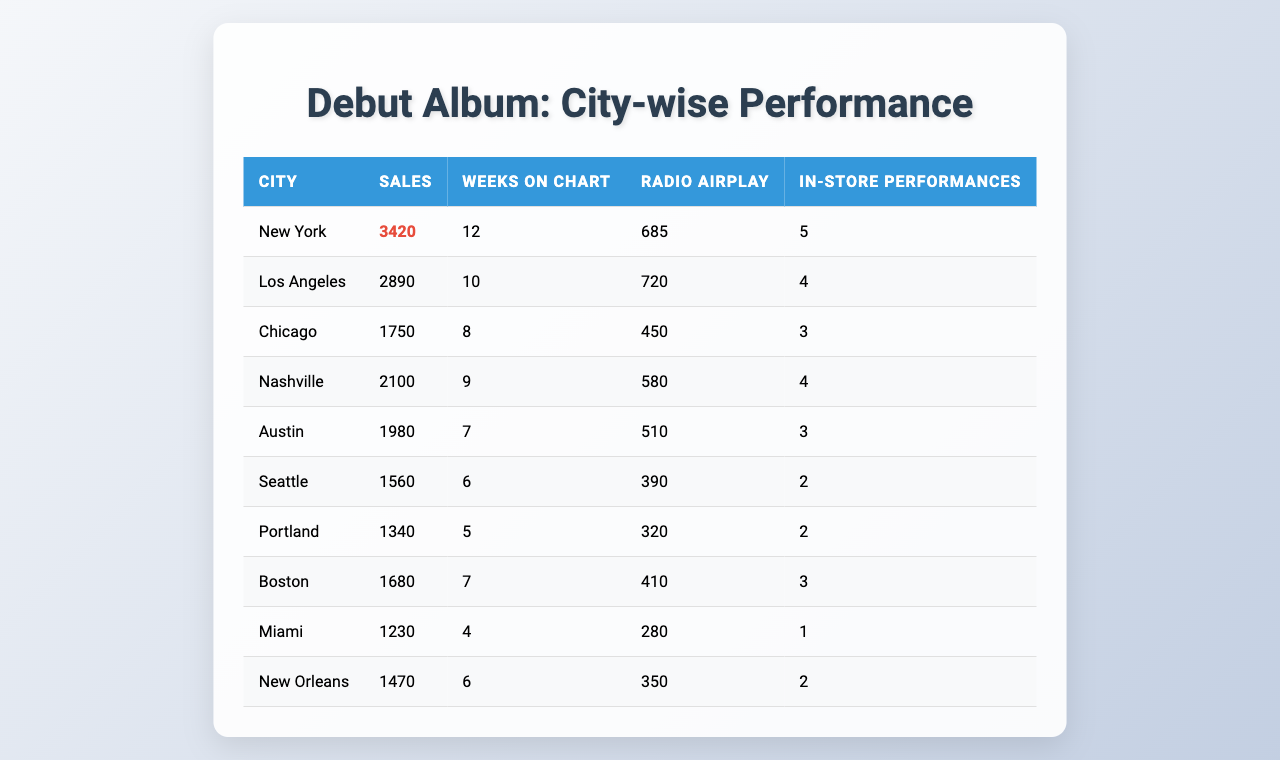What city had the highest sales? By looking at the "Sales" column in the table, New York has the highest sales figure at 3420.
Answer: New York Which city had the least number of in-store performances? Examining the "In-store Performances" column, Miami has the least with only 1 performance.
Answer: Miami What is the average number of weeks on the chart across all cities? To find the average, sum the weeks (12 + 10 + 8 + 9 + 7 + 6 + 5 + 7 + 4 + 6 = 78) and divide by the number of cities (78 / 10 = 7.8).
Answer: 7.8 Which city has more radio airplay than Chicago? By comparing the "Radio Airplay" of Chicago (450) with other cities, New York (685), Los Angeles (720), Nashville (580), and Austin (510) have higher airplay than Chicago.
Answer: New York, Los Angeles, Nashville, Austin Is it true that Austin had more sales than New Orleans? Austin's sales are 1980, while New Orleans' sales are 1230. Since 1980 > 1230, this statement is true.
Answer: Yes What is the total radio airplay across all cities? The total airplay is calculated by summing the values: (685 + 720 + 450 + 580 + 510 + 390 + 320 + 410 + 280 + 350 = 4275).
Answer: 4275 Which city has the best performance in sales relative to the number of weeks on the chart? To determine this, calculate sales per week for each city. For example, New York's sales per week are 3420/12 = 285. Chicago's are 1750/8 = 218. New York has the highest ratio compared to others.
Answer: New York How many cities had more than 2000 sales? By checking the "Sales" column, New York (3420), Los Angeles (2890), and Nashville (2100) all have sales greater than 2000. This counts as three cities.
Answer: 3 What is the difference in sales between New York and Miami? To find this difference, subtract Miami's sales (1230) from New York's sales (3420): 3420 - 1230 = 2190.
Answer: 2190 Which city had the highest number of weeks on the chart and what were their sales? The city with the most weeks on the chart is New York with 12 weeks, and its sales were 3420.
Answer: New York, 3420 